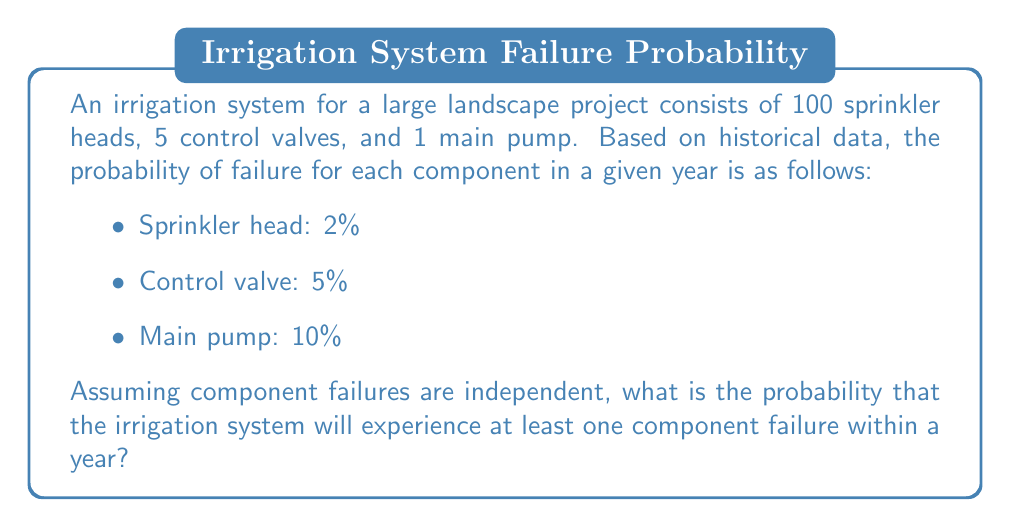Show me your answer to this math problem. To solve this problem, we'll use the complementary probability approach:

1. First, let's calculate the probability that each component type does not fail:

   For a sprinkler head: $P(\text{no failure}) = 1 - 0.02 = 0.98$
   For a control valve: $P(\text{no failure}) = 1 - 0.05 = 0.95$
   For the main pump: $P(\text{no failure}) = 1 - 0.10 = 0.90$

2. Now, we need to calculate the probability that all components do not fail:

   $P(\text{no failures}) = (0.98)^{100} \times (0.95)^5 \times 0.90$

   This is because we need all 100 sprinkler heads, all 5 control valves, and the main pump to not fail.

3. We can simplify this calculation:

   $P(\text{no failures}) = (0.98)^{100} \times (0.95)^5 \times 0.90 \approx 0.1301$

4. The probability of at least one failure is the complement of the probability of no failures:

   $P(\text{at least one failure}) = 1 - P(\text{no failures})$
   $P(\text{at least one failure}) = 1 - 0.1301 \approx 0.8699$

Therefore, the probability that the irrigation system will experience at least one component failure within a year is approximately 0.8699 or 86.99%.
Answer: The probability of at least one component failure in the irrigation system within a year is approximately 0.8699 or 86.99%. 